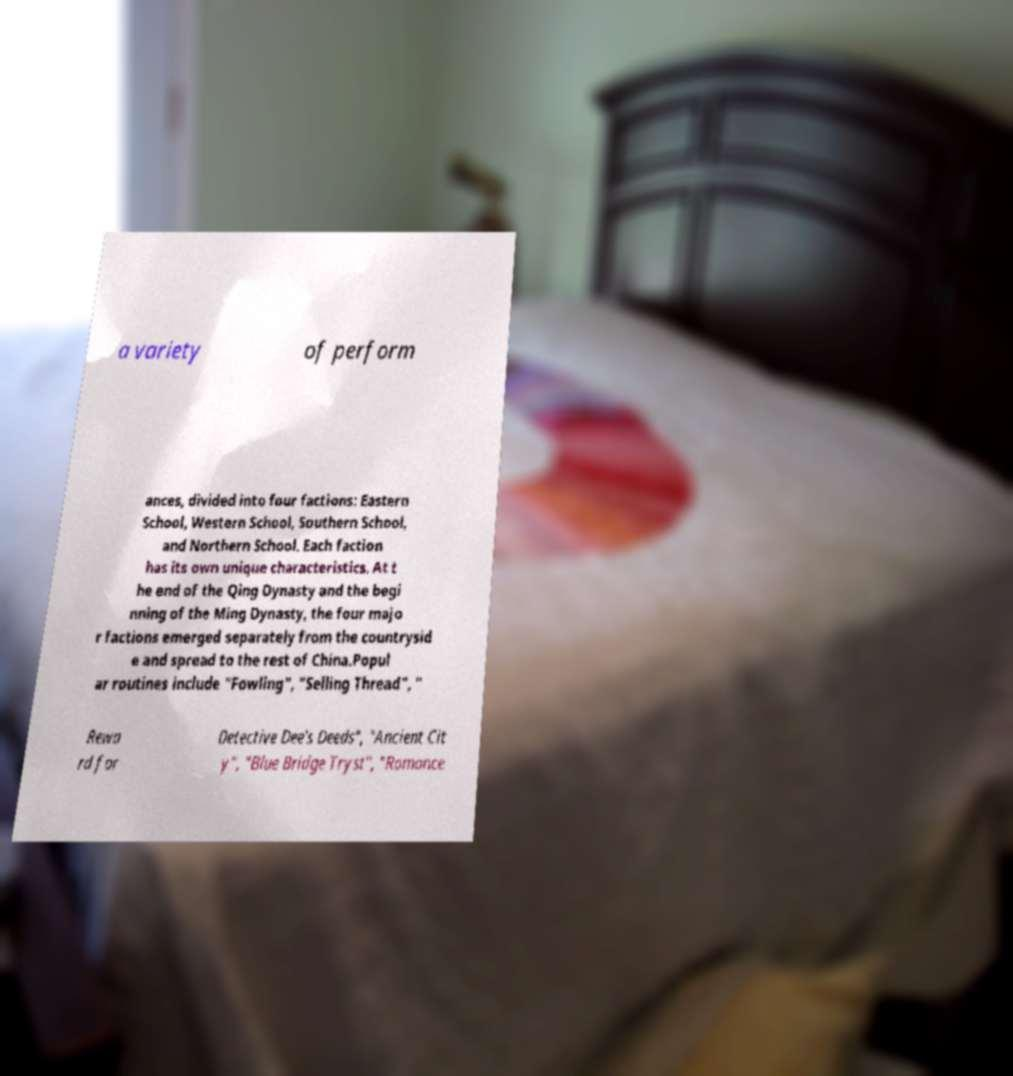Please read and relay the text visible in this image. What does it say? a variety of perform ances, divided into four factions: Eastern School, Western School, Southern School, and Northern School. Each faction has its own unique characteristics. At t he end of the Qing Dynasty and the begi nning of the Ming Dynasty, the four majo r factions emerged separately from the countrysid e and spread to the rest of China.Popul ar routines include "Fowling", "Selling Thread", " Rewa rd for Detective Dee's Deeds", "Ancient Cit y", "Blue Bridge Tryst", "Romance 